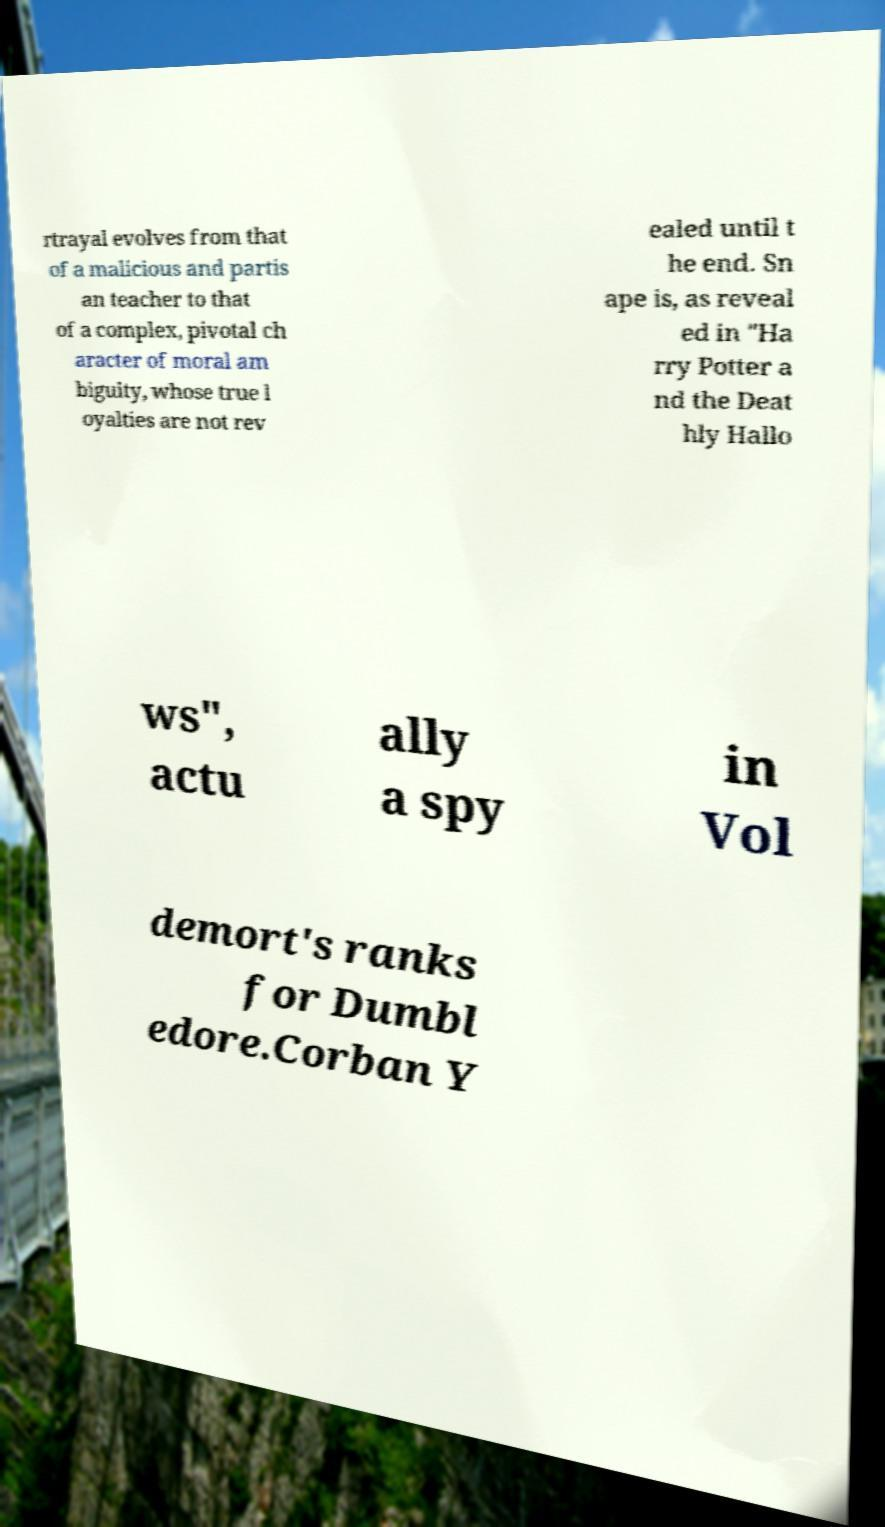Could you assist in decoding the text presented in this image and type it out clearly? rtrayal evolves from that of a malicious and partis an teacher to that of a complex, pivotal ch aracter of moral am biguity, whose true l oyalties are not rev ealed until t he end. Sn ape is, as reveal ed in "Ha rry Potter a nd the Deat hly Hallo ws", actu ally a spy in Vol demort's ranks for Dumbl edore.Corban Y 